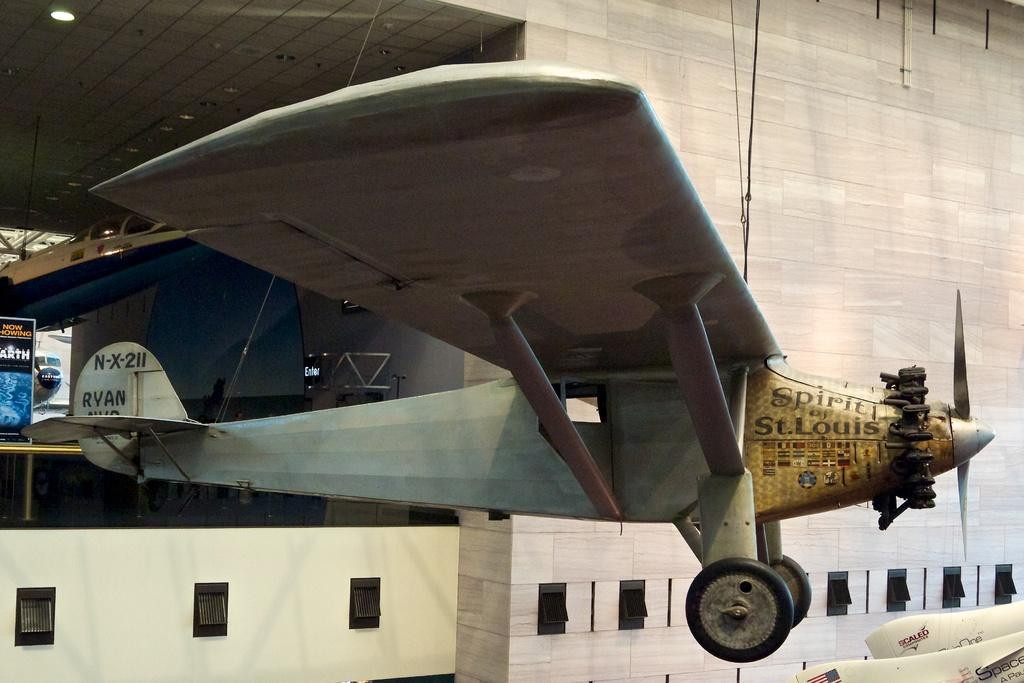What is the main subject of the image? The main subject of the image is airplanes. What other objects can be seen in the image besides airplanes? There are boards, a wall, a rope, a light, and windows in the image. What type of hate can be seen in the image? There is no hate present in the image; it features airplanes and other objects. Who is the creator of the windows in the image? The image does not provide information about the creator of the windows; it simply shows their presence in the scene. 